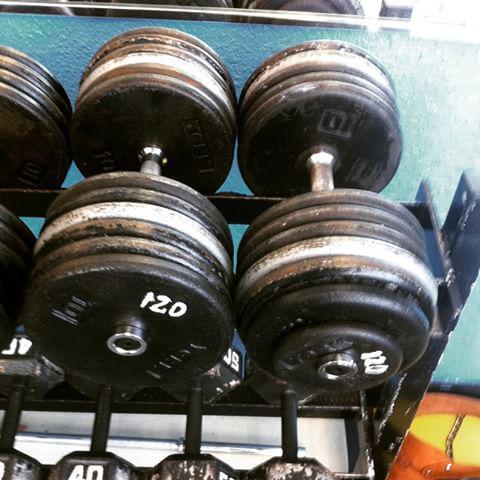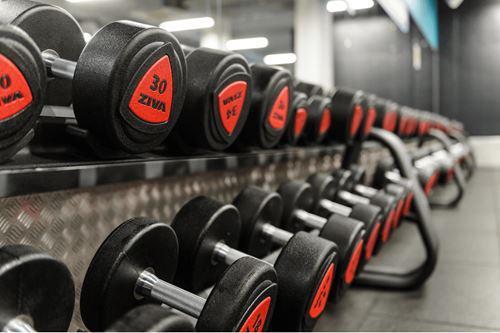The first image is the image on the left, the second image is the image on the right. Evaluate the accuracy of this statement regarding the images: "There is at least one man visible exercising". Is it true? Answer yes or no. No. The first image is the image on the left, the second image is the image on the right. For the images displayed, is the sentence "One image shows a human doing pushups." factually correct? Answer yes or no. No. 